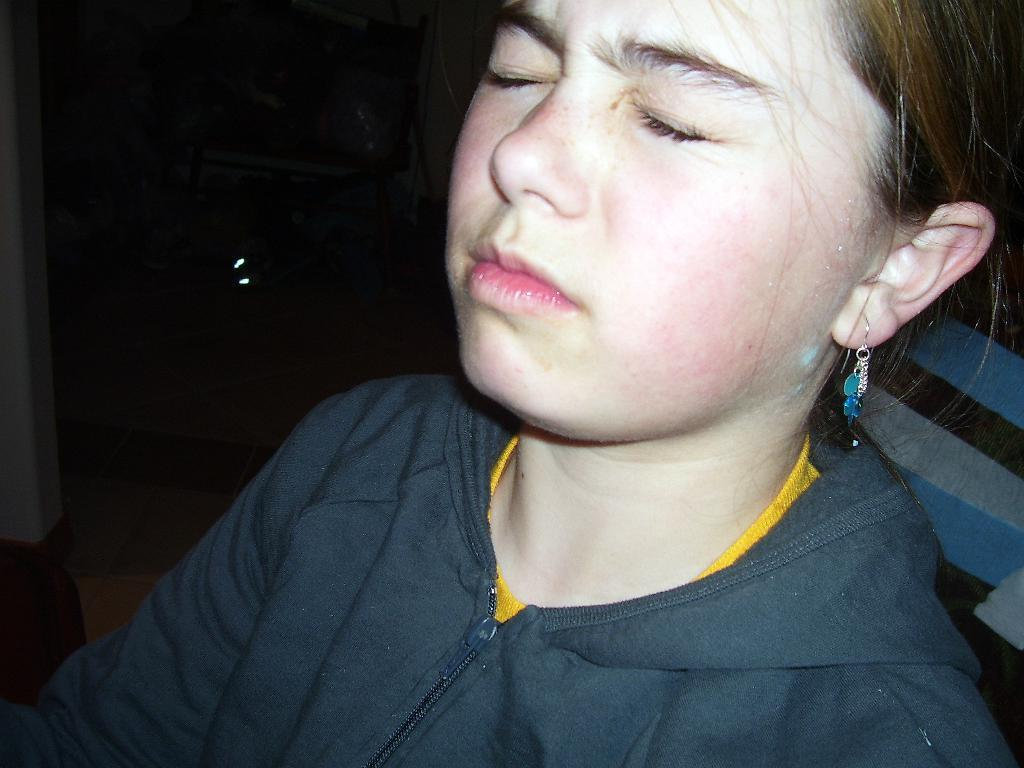Who is the main subject in the image? There is a girl in the image. What is the girl wearing? The girl is wearing a black jacket. What is the girl doing in the image? The girl is closing her eyes. What can be seen on the left side of the image? There is a wall on the left side of the image. How would you describe the overall lighting in the image? The background of the image is dark. What type of operation is the girl performing in the image? There is no indication of an operation in the image; the girl is simply closing her eyes. What part of the mine is visible in the image? There is no mine present in the image; it features a girl wearing a black jacket and closing her eyes. 